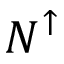<formula> <loc_0><loc_0><loc_500><loc_500>N ^ { \uparrow }</formula> 